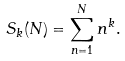<formula> <loc_0><loc_0><loc_500><loc_500>S _ { k } ( N ) = \sum ^ { N } _ { n = 1 } n ^ { k } .</formula> 